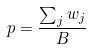Convert formula to latex. <formula><loc_0><loc_0><loc_500><loc_500>p = \frac { \sum _ { j } w _ { j } } { B }</formula> 